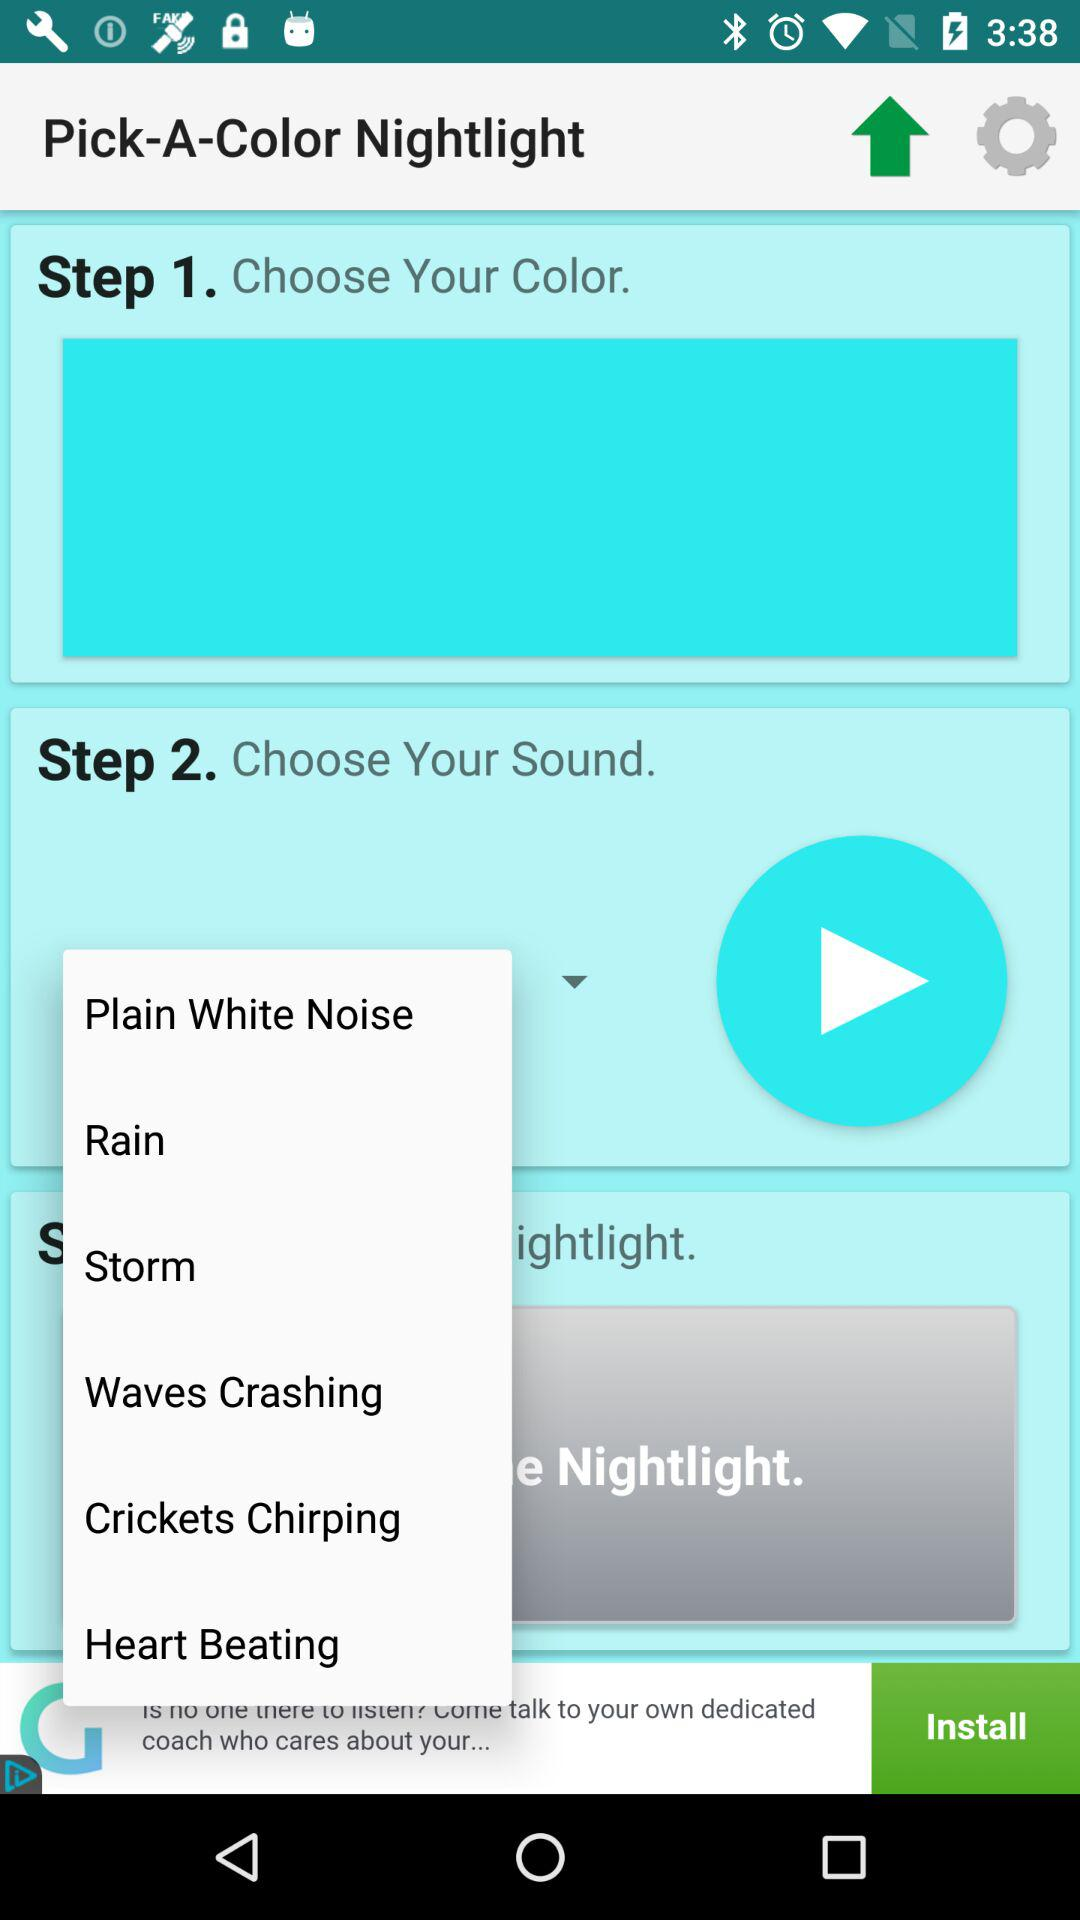What to choose at step 2? At step 2, choose sound. 